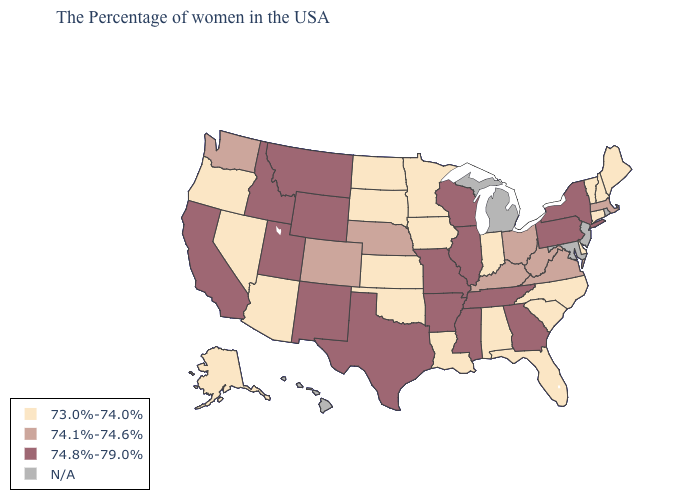What is the value of South Dakota?
Answer briefly. 73.0%-74.0%. Name the states that have a value in the range 73.0%-74.0%?
Write a very short answer. Maine, New Hampshire, Vermont, Connecticut, Delaware, North Carolina, South Carolina, Florida, Indiana, Alabama, Louisiana, Minnesota, Iowa, Kansas, Oklahoma, South Dakota, North Dakota, Arizona, Nevada, Oregon, Alaska. Which states have the lowest value in the USA?
Answer briefly. Maine, New Hampshire, Vermont, Connecticut, Delaware, North Carolina, South Carolina, Florida, Indiana, Alabama, Louisiana, Minnesota, Iowa, Kansas, Oklahoma, South Dakota, North Dakota, Arizona, Nevada, Oregon, Alaska. Among the states that border Kentucky , which have the highest value?
Short answer required. Tennessee, Illinois, Missouri. Which states have the lowest value in the USA?
Quick response, please. Maine, New Hampshire, Vermont, Connecticut, Delaware, North Carolina, South Carolina, Florida, Indiana, Alabama, Louisiana, Minnesota, Iowa, Kansas, Oklahoma, South Dakota, North Dakota, Arizona, Nevada, Oregon, Alaska. What is the highest value in states that border Illinois?
Answer briefly. 74.8%-79.0%. Does the map have missing data?
Keep it brief. Yes. Name the states that have a value in the range 74.1%-74.6%?
Quick response, please. Massachusetts, Virginia, West Virginia, Ohio, Kentucky, Nebraska, Colorado, Washington. What is the value of Colorado?
Answer briefly. 74.1%-74.6%. Name the states that have a value in the range 74.1%-74.6%?
Keep it brief. Massachusetts, Virginia, West Virginia, Ohio, Kentucky, Nebraska, Colorado, Washington. Name the states that have a value in the range N/A?
Give a very brief answer. Rhode Island, New Jersey, Maryland, Michigan, Hawaii. Name the states that have a value in the range 73.0%-74.0%?
Be succinct. Maine, New Hampshire, Vermont, Connecticut, Delaware, North Carolina, South Carolina, Florida, Indiana, Alabama, Louisiana, Minnesota, Iowa, Kansas, Oklahoma, South Dakota, North Dakota, Arizona, Nevada, Oregon, Alaska. Is the legend a continuous bar?
Quick response, please. No. How many symbols are there in the legend?
Short answer required. 4. Does Arkansas have the lowest value in the South?
Answer briefly. No. 